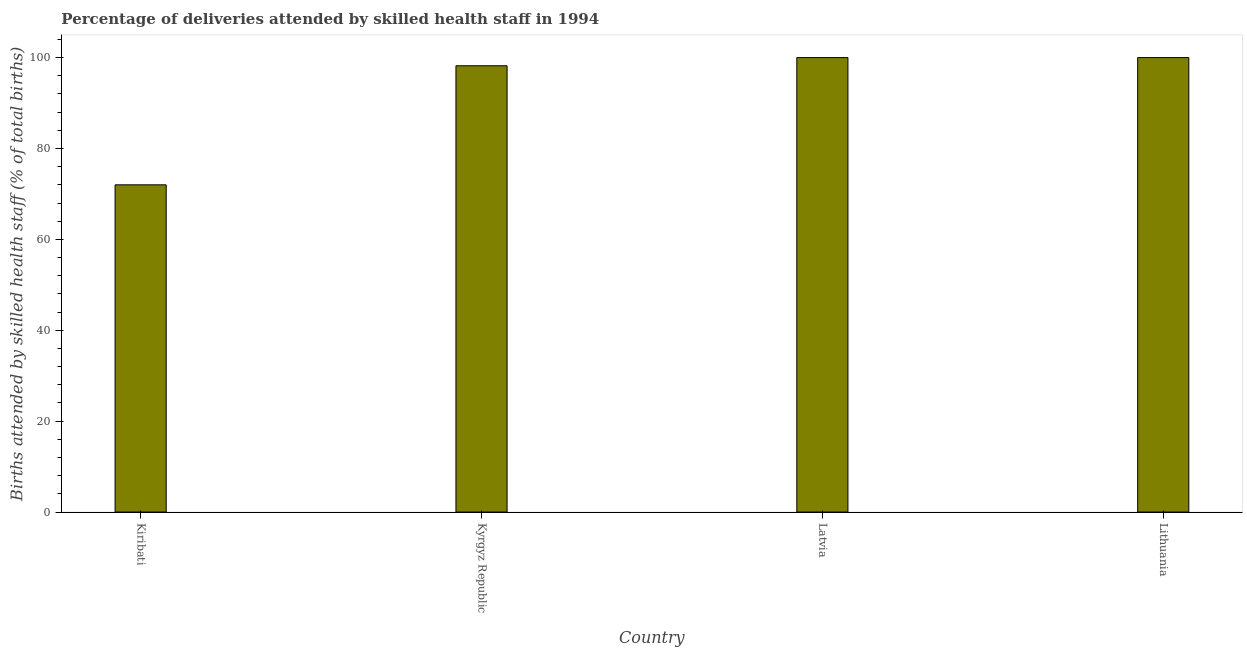Does the graph contain any zero values?
Ensure brevity in your answer.  No. Does the graph contain grids?
Offer a very short reply. No. What is the title of the graph?
Offer a terse response. Percentage of deliveries attended by skilled health staff in 1994. What is the label or title of the Y-axis?
Make the answer very short. Births attended by skilled health staff (% of total births). Across all countries, what is the minimum number of births attended by skilled health staff?
Provide a succinct answer. 72. In which country was the number of births attended by skilled health staff maximum?
Your answer should be compact. Latvia. In which country was the number of births attended by skilled health staff minimum?
Provide a short and direct response. Kiribati. What is the sum of the number of births attended by skilled health staff?
Provide a short and direct response. 370.2. What is the difference between the number of births attended by skilled health staff in Kyrgyz Republic and Latvia?
Offer a very short reply. -1.8. What is the average number of births attended by skilled health staff per country?
Ensure brevity in your answer.  92.55. What is the median number of births attended by skilled health staff?
Offer a very short reply. 99.1. In how many countries, is the number of births attended by skilled health staff greater than 44 %?
Provide a succinct answer. 4. What is the ratio of the number of births attended by skilled health staff in Kiribati to that in Lithuania?
Your answer should be very brief. 0.72. Is the number of births attended by skilled health staff in Kiribati less than that in Latvia?
Your answer should be very brief. Yes. What is the difference between the highest and the second highest number of births attended by skilled health staff?
Give a very brief answer. 0. Is the sum of the number of births attended by skilled health staff in Kyrgyz Republic and Latvia greater than the maximum number of births attended by skilled health staff across all countries?
Your answer should be very brief. Yes. How many bars are there?
Your answer should be very brief. 4. How many countries are there in the graph?
Keep it short and to the point. 4. What is the difference between two consecutive major ticks on the Y-axis?
Your answer should be very brief. 20. What is the Births attended by skilled health staff (% of total births) in Kiribati?
Offer a terse response. 72. What is the Births attended by skilled health staff (% of total births) in Kyrgyz Republic?
Your response must be concise. 98.2. What is the Births attended by skilled health staff (% of total births) in Latvia?
Ensure brevity in your answer.  100. What is the Births attended by skilled health staff (% of total births) of Lithuania?
Make the answer very short. 100. What is the difference between the Births attended by skilled health staff (% of total births) in Kiribati and Kyrgyz Republic?
Your answer should be compact. -26.2. What is the difference between the Births attended by skilled health staff (% of total births) in Kiribati and Latvia?
Ensure brevity in your answer.  -28. What is the difference between the Births attended by skilled health staff (% of total births) in Kiribati and Lithuania?
Your answer should be compact. -28. What is the difference between the Births attended by skilled health staff (% of total births) in Kyrgyz Republic and Latvia?
Offer a very short reply. -1.8. What is the difference between the Births attended by skilled health staff (% of total births) in Kyrgyz Republic and Lithuania?
Offer a very short reply. -1.8. What is the difference between the Births attended by skilled health staff (% of total births) in Latvia and Lithuania?
Provide a short and direct response. 0. What is the ratio of the Births attended by skilled health staff (% of total births) in Kiribati to that in Kyrgyz Republic?
Make the answer very short. 0.73. What is the ratio of the Births attended by skilled health staff (% of total births) in Kiribati to that in Latvia?
Provide a short and direct response. 0.72. What is the ratio of the Births attended by skilled health staff (% of total births) in Kiribati to that in Lithuania?
Your response must be concise. 0.72. What is the ratio of the Births attended by skilled health staff (% of total births) in Kyrgyz Republic to that in Latvia?
Offer a terse response. 0.98. What is the ratio of the Births attended by skilled health staff (% of total births) in Latvia to that in Lithuania?
Give a very brief answer. 1. 